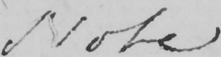What is written in this line of handwriting? Note 